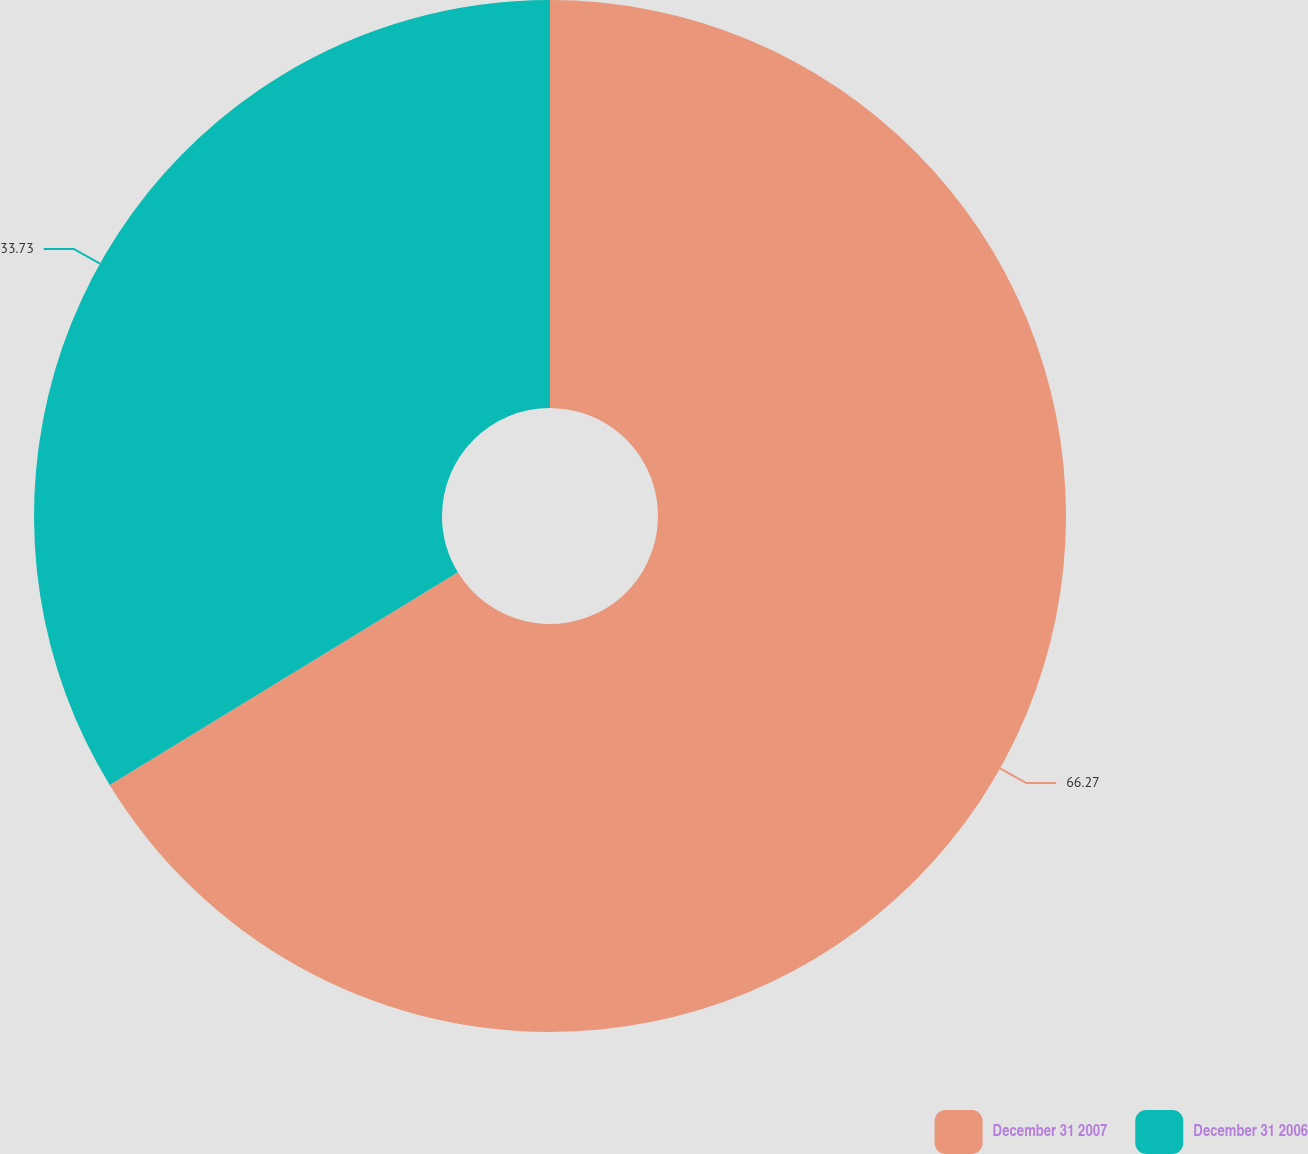<chart> <loc_0><loc_0><loc_500><loc_500><pie_chart><fcel>December 31 2007<fcel>December 31 2006<nl><fcel>66.27%<fcel>33.73%<nl></chart> 